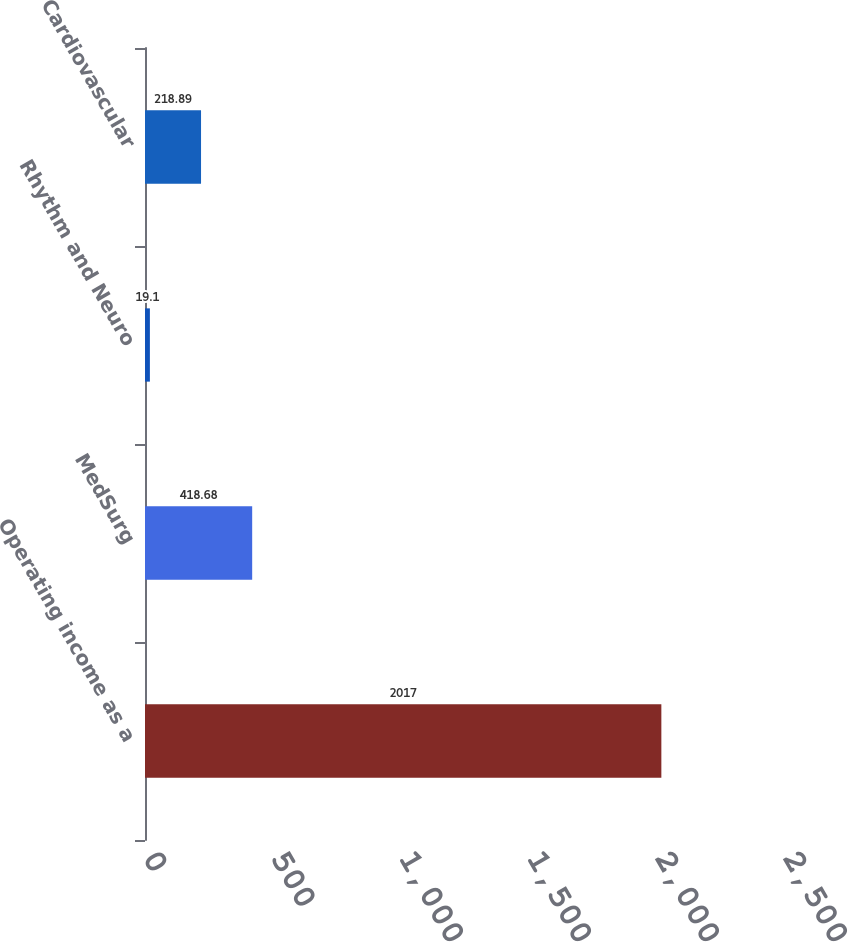Convert chart to OTSL. <chart><loc_0><loc_0><loc_500><loc_500><bar_chart><fcel>Operating income as a<fcel>MedSurg<fcel>Rhythm and Neuro<fcel>Cardiovascular<nl><fcel>2017<fcel>418.68<fcel>19.1<fcel>218.89<nl></chart> 